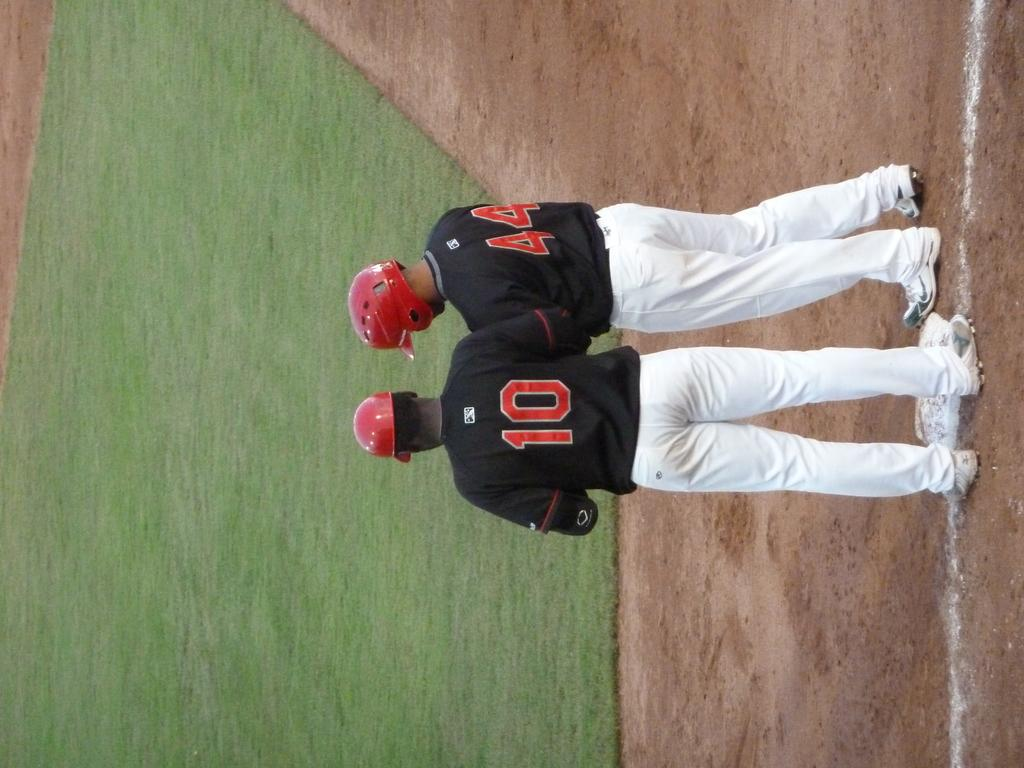<image>
Give a short and clear explanation of the subsequent image. Two baseball players with numbers 10 and 44 standing at the field. 